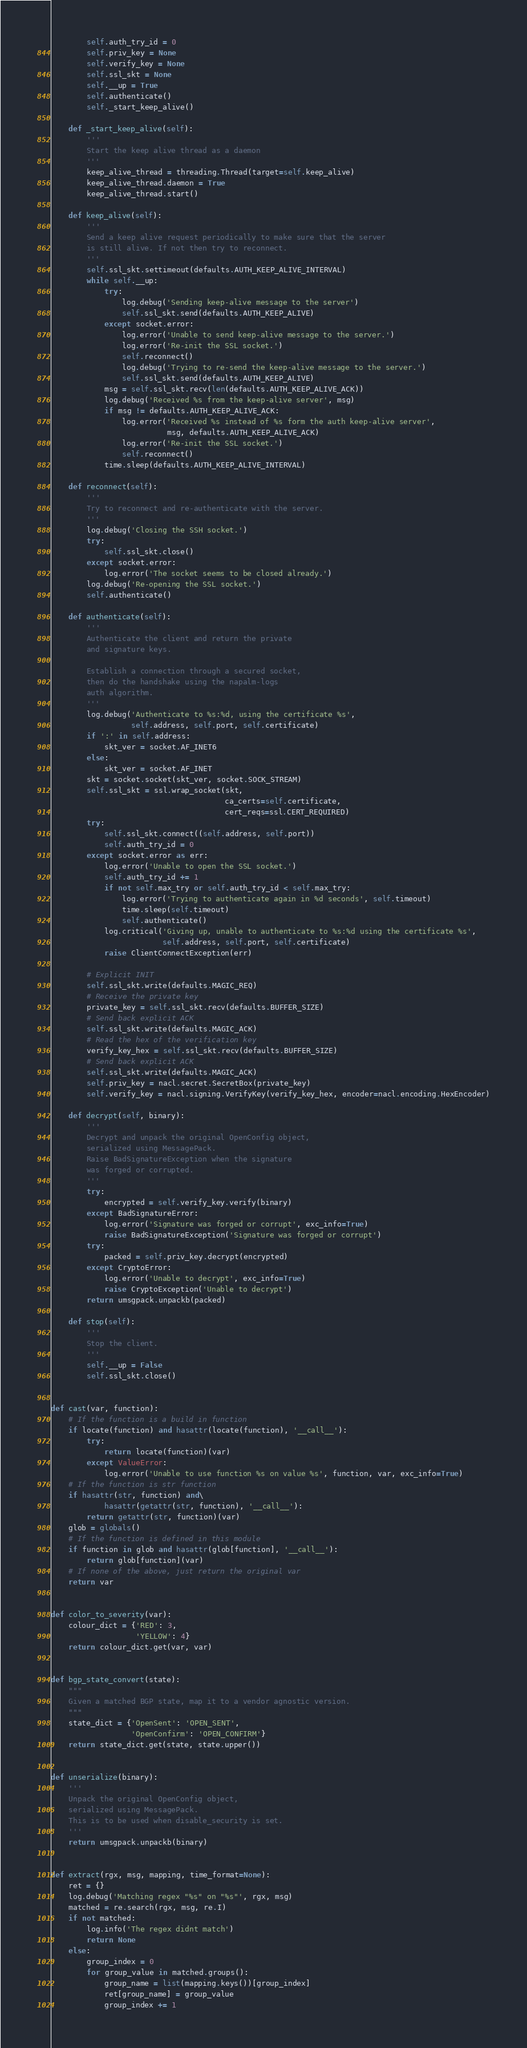<code> <loc_0><loc_0><loc_500><loc_500><_Python_>        self.auth_try_id = 0
        self.priv_key = None
        self.verify_key = None
        self.ssl_skt = None
        self.__up = True
        self.authenticate()
        self._start_keep_alive()

    def _start_keep_alive(self):
        '''
        Start the keep alive thread as a daemon
        '''
        keep_alive_thread = threading.Thread(target=self.keep_alive)
        keep_alive_thread.daemon = True
        keep_alive_thread.start()

    def keep_alive(self):
        '''
        Send a keep alive request periodically to make sure that the server
        is still alive. If not then try to reconnect.
        '''
        self.ssl_skt.settimeout(defaults.AUTH_KEEP_ALIVE_INTERVAL)
        while self.__up:
            try:
                log.debug('Sending keep-alive message to the server')
                self.ssl_skt.send(defaults.AUTH_KEEP_ALIVE)
            except socket.error:
                log.error('Unable to send keep-alive message to the server.')
                log.error('Re-init the SSL socket.')
                self.reconnect()
                log.debug('Trying to re-send the keep-alive message to the server.')
                self.ssl_skt.send(defaults.AUTH_KEEP_ALIVE)
            msg = self.ssl_skt.recv(len(defaults.AUTH_KEEP_ALIVE_ACK))
            log.debug('Received %s from the keep-alive server', msg)
            if msg != defaults.AUTH_KEEP_ALIVE_ACK:
                log.error('Received %s instead of %s form the auth keep-alive server',
                          msg, defaults.AUTH_KEEP_ALIVE_ACK)
                log.error('Re-init the SSL socket.')
                self.reconnect()
            time.sleep(defaults.AUTH_KEEP_ALIVE_INTERVAL)

    def reconnect(self):
        '''
        Try to reconnect and re-authenticate with the server.
        '''
        log.debug('Closing the SSH socket.')
        try:
            self.ssl_skt.close()
        except socket.error:
            log.error('The socket seems to be closed already.')
        log.debug('Re-opening the SSL socket.')
        self.authenticate()

    def authenticate(self):
        '''
        Authenticate the client and return the private
        and signature keys.

        Establish a connection through a secured socket,
        then do the handshake using the napalm-logs
        auth algorithm.
        '''
        log.debug('Authenticate to %s:%d, using the certificate %s',
                  self.address, self.port, self.certificate)
        if ':' in self.address:
            skt_ver = socket.AF_INET6
        else:
            skt_ver = socket.AF_INET
        skt = socket.socket(skt_ver, socket.SOCK_STREAM)
        self.ssl_skt = ssl.wrap_socket(skt,
                                       ca_certs=self.certificate,
                                       cert_reqs=ssl.CERT_REQUIRED)
        try:
            self.ssl_skt.connect((self.address, self.port))
            self.auth_try_id = 0
        except socket.error as err:
            log.error('Unable to open the SSL socket.')
            self.auth_try_id += 1
            if not self.max_try or self.auth_try_id < self.max_try:
                log.error('Trying to authenticate again in %d seconds', self.timeout)
                time.sleep(self.timeout)
                self.authenticate()
            log.critical('Giving up, unable to authenticate to %s:%d using the certificate %s',
                         self.address, self.port, self.certificate)
            raise ClientConnectException(err)

        # Explicit INIT
        self.ssl_skt.write(defaults.MAGIC_REQ)
        # Receive the private key
        private_key = self.ssl_skt.recv(defaults.BUFFER_SIZE)
        # Send back explicit ACK
        self.ssl_skt.write(defaults.MAGIC_ACK)
        # Read the hex of the verification key
        verify_key_hex = self.ssl_skt.recv(defaults.BUFFER_SIZE)
        # Send back explicit ACK
        self.ssl_skt.write(defaults.MAGIC_ACK)
        self.priv_key = nacl.secret.SecretBox(private_key)
        self.verify_key = nacl.signing.VerifyKey(verify_key_hex, encoder=nacl.encoding.HexEncoder)

    def decrypt(self, binary):
        '''
        Decrypt and unpack the original OpenConfig object,
        serialized using MessagePack.
        Raise BadSignatureException when the signature
        was forged or corrupted.
        '''
        try:
            encrypted = self.verify_key.verify(binary)
        except BadSignatureError:
            log.error('Signature was forged or corrupt', exc_info=True)
            raise BadSignatureException('Signature was forged or corrupt')
        try:
            packed = self.priv_key.decrypt(encrypted)
        except CryptoError:
            log.error('Unable to decrypt', exc_info=True)
            raise CryptoException('Unable to decrypt')
        return umsgpack.unpackb(packed)

    def stop(self):
        '''
        Stop the client.
        '''
        self.__up = False
        self.ssl_skt.close()


def cast(var, function):
    # If the function is a build in function
    if locate(function) and hasattr(locate(function), '__call__'):
        try:
            return locate(function)(var)
        except ValueError:
            log.error('Unable to use function %s on value %s', function, var, exc_info=True)
    # If the function is str function
    if hasattr(str, function) and\
            hasattr(getattr(str, function), '__call__'):
        return getattr(str, function)(var)
    glob = globals()
    # If the function is defined in this module
    if function in glob and hasattr(glob[function], '__call__'):
        return glob[function](var)
    # If none of the above, just return the original var
    return var


def color_to_severity(var):
    colour_dict = {'RED': 3,
                   'YELLOW': 4}
    return colour_dict.get(var, var)


def bgp_state_convert(state):
    """
    Given a matched BGP state, map it to a vendor agnostic version.
    """
    state_dict = {'OpenSent': 'OPEN_SENT',
                  'OpenConfirm': 'OPEN_CONFIRM'}
    return state_dict.get(state, state.upper())


def unserialize(binary):
    '''
    Unpack the original OpenConfig object,
    serialized using MessagePack.
    This is to be used when disable_security is set.
    '''
    return umsgpack.unpackb(binary)


def extract(rgx, msg, mapping, time_format=None):
    ret = {}
    log.debug('Matching regex "%s" on "%s"', rgx, msg)
    matched = re.search(rgx, msg, re.I)
    if not matched:
        log.info('The regex didnt match')
        return None
    else:
        group_index = 0
        for group_value in matched.groups():
            group_name = list(mapping.keys())[group_index]
            ret[group_name] = group_value
            group_index += 1</code> 